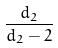Convert formula to latex. <formula><loc_0><loc_0><loc_500><loc_500>\frac { d _ { 2 } } { d _ { 2 } - 2 }</formula> 